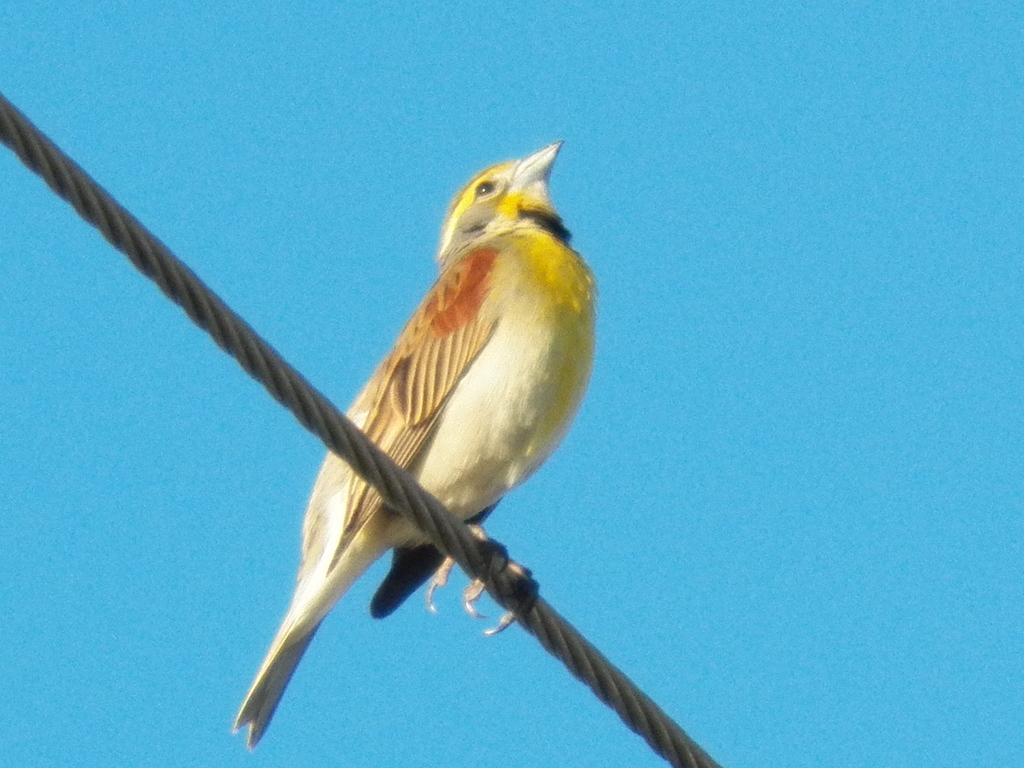What type of animal is in the image? There is a bird in the image. Where is the bird located? The bird is on a rope. What can be seen behind the bird? The sky is visible behind the bird. What emotion does the bird display in the image? The bird's emotions cannot be determined from the image, as birds do not display emotions in the same way humans do. 